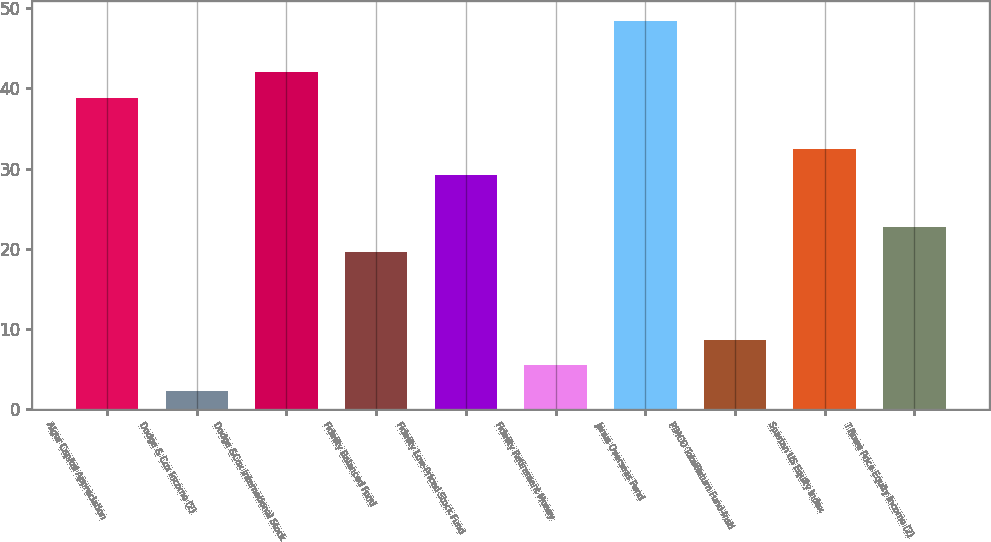Convert chart. <chart><loc_0><loc_0><loc_500><loc_500><bar_chart><fcel>Alger Capital Appreciation<fcel>Dodge & Cox Income (2)<fcel>Dodge &Cox International Stock<fcel>Fidelity Balanced Fund<fcel>Fidelity Low-Priced Stock Fund<fcel>Fidelity Retirement Money<fcel>Janus Overseas Fund<fcel>PIMCO TotalReturn Fund-Instl<fcel>Spartan US Equity Index<fcel>T Rowe Price Equity Income (2)<nl><fcel>38.82<fcel>2.26<fcel>42.03<fcel>19.56<fcel>29.19<fcel>5.47<fcel>48.45<fcel>8.68<fcel>32.4<fcel>22.77<nl></chart> 